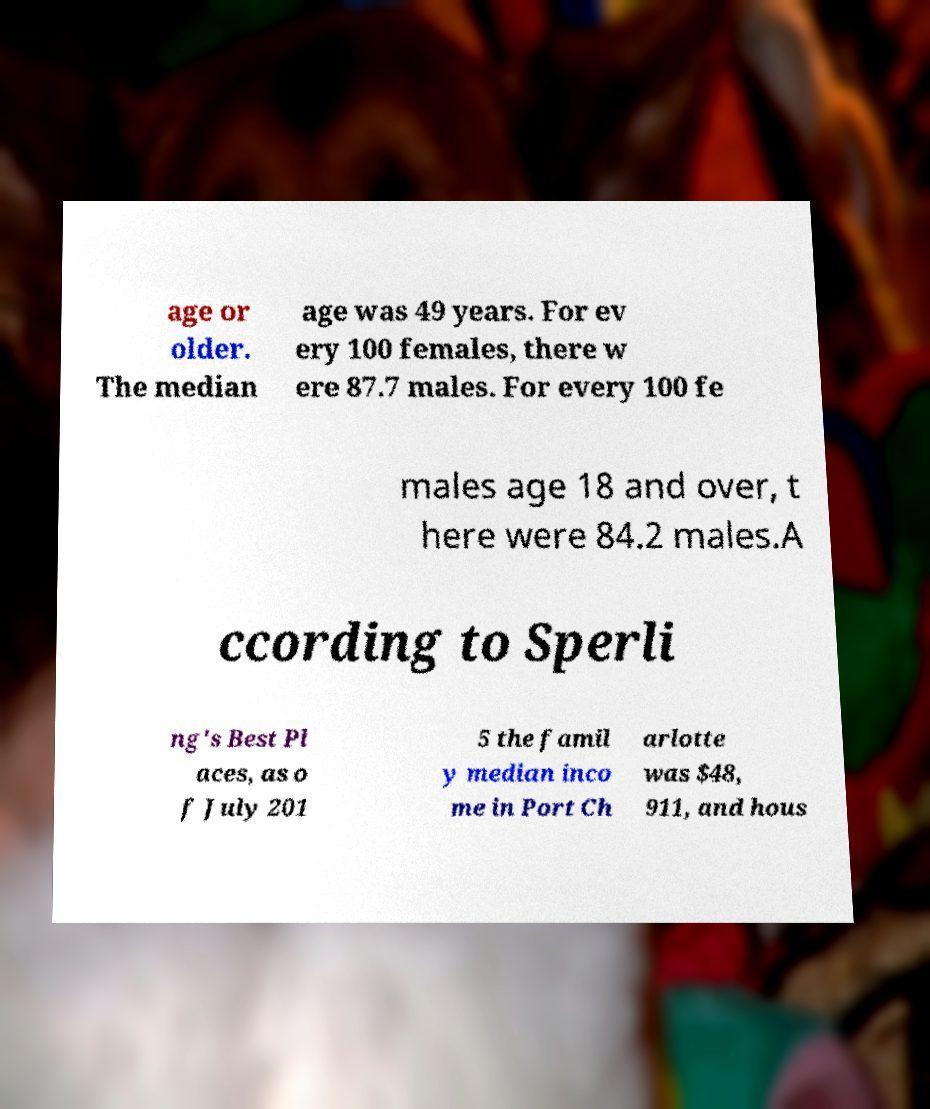Please identify and transcribe the text found in this image. age or older. The median age was 49 years. For ev ery 100 females, there w ere 87.7 males. For every 100 fe males age 18 and over, t here were 84.2 males.A ccording to Sperli ng's Best Pl aces, as o f July 201 5 the famil y median inco me in Port Ch arlotte was $48, 911, and hous 